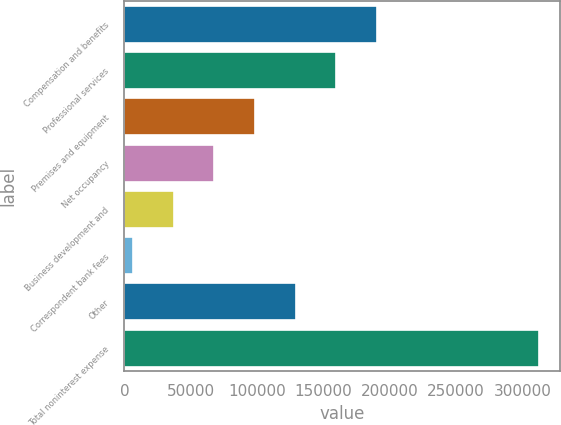Convert chart. <chart><loc_0><loc_0><loc_500><loc_500><bar_chart><fcel>Compensation and benefits<fcel>Professional services<fcel>Premises and equipment<fcel>Net occupancy<fcel>Business development and<fcel>Correspondent bank fees<fcel>Other<fcel>Total noninterest expense<nl><fcel>190383<fcel>159758<fcel>98505.7<fcel>67879.8<fcel>37253.9<fcel>6628<fcel>129132<fcel>312887<nl></chart> 